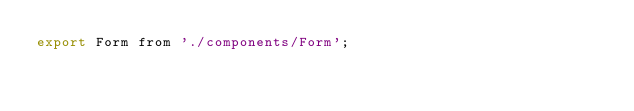Convert code to text. <code><loc_0><loc_0><loc_500><loc_500><_JavaScript_>export Form from './components/Form';
</code> 